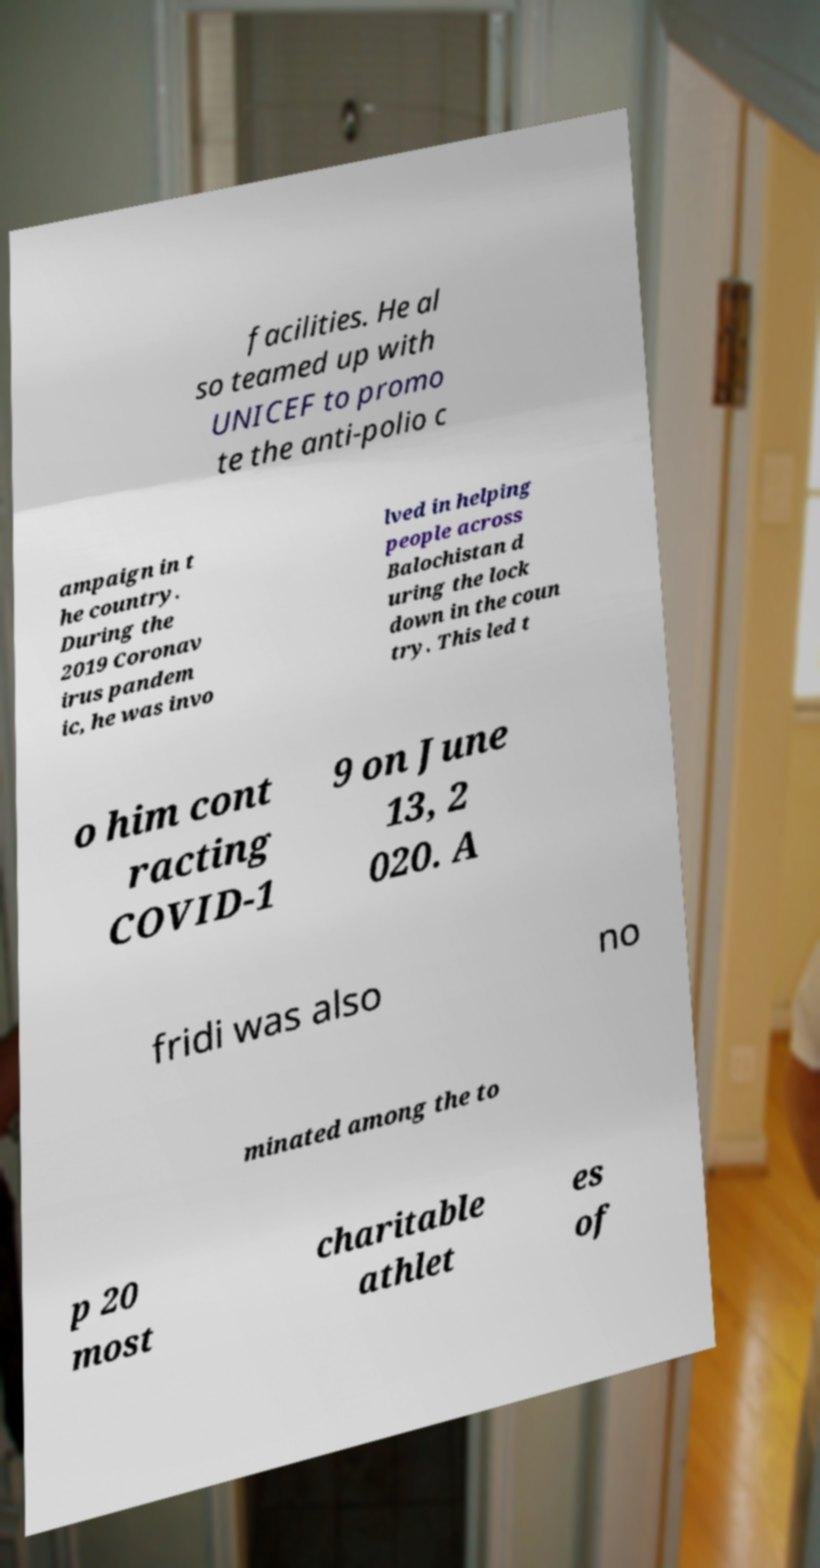Please identify and transcribe the text found in this image. facilities. He al so teamed up with UNICEF to promo te the anti-polio c ampaign in t he country. During the 2019 Coronav irus pandem ic, he was invo lved in helping people across Balochistan d uring the lock down in the coun try. This led t o him cont racting COVID-1 9 on June 13, 2 020. A fridi was also no minated among the to p 20 most charitable athlet es of 